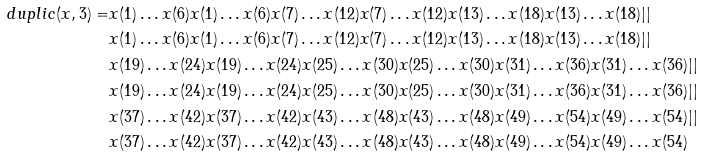<formula> <loc_0><loc_0><loc_500><loc_500>d u p l i c ( x , 3 ) = & x ( 1 ) \dots x ( 6 ) x ( 1 ) \dots x ( 6 ) x ( 7 ) \dots x ( 1 2 ) x ( 7 ) \dots x ( 1 2 ) x ( 1 3 ) \dots x ( 1 8 ) x ( 1 3 ) \dots x ( 1 8 ) | | \\ & x ( 1 ) \dots x ( 6 ) x ( 1 ) \dots x ( 6 ) x ( 7 ) \dots x ( 1 2 ) x ( 7 ) \dots x ( 1 2 ) x ( 1 3 ) \dots x ( 1 8 ) x ( 1 3 ) \dots x ( 1 8 ) | | \\ & x ( 1 9 ) \dots x ( 2 4 ) x ( 1 9 ) \dots x ( 2 4 ) x ( 2 5 ) \dots x ( 3 0 ) x ( 2 5 ) \dots x ( 3 0 ) x ( 3 1 ) \dots x ( 3 6 ) x ( 3 1 ) \dots x ( 3 6 ) | | \\ & x ( 1 9 ) \dots x ( 2 4 ) x ( 1 9 ) \dots x ( 2 4 ) x ( 2 5 ) \dots x ( 3 0 ) x ( 2 5 ) \dots x ( 3 0 ) x ( 3 1 ) \dots x ( 3 6 ) x ( 3 1 ) \dots x ( 3 6 ) | | \\ & x ( 3 7 ) \dots x ( 4 2 ) x ( 3 7 ) \dots x ( 4 2 ) x ( 4 3 ) \dots x ( 4 8 ) x ( 4 3 ) \dots x ( 4 8 ) x ( 4 9 ) \dots x ( 5 4 ) x ( 4 9 ) \dots x ( 5 4 ) | | \\ & x ( 3 7 ) \dots x ( 4 2 ) x ( 3 7 ) \dots x ( 4 2 ) x ( 4 3 ) \dots x ( 4 8 ) x ( 4 3 ) \dots x ( 4 8 ) x ( 4 9 ) \dots x ( 5 4 ) x ( 4 9 ) \dots x ( 5 4 )</formula> 